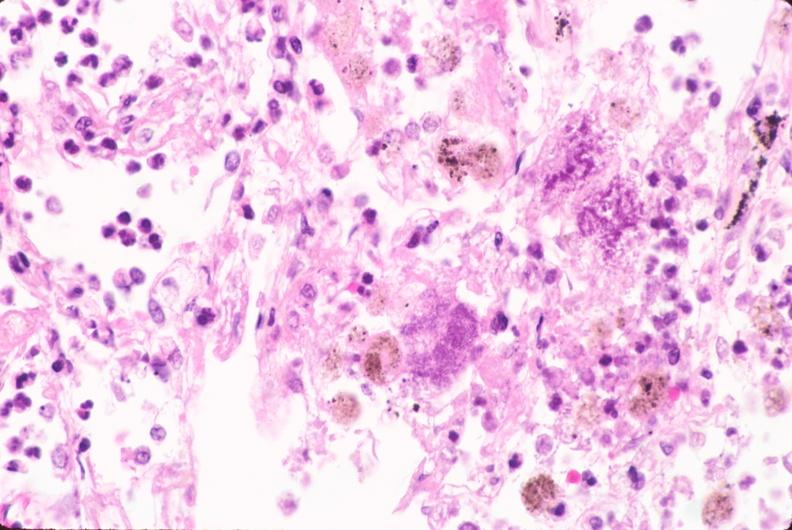does absence of palpebral fissure cleft palate show lung, bronchopneumonia, bacterial?
Answer the question using a single word or phrase. No 